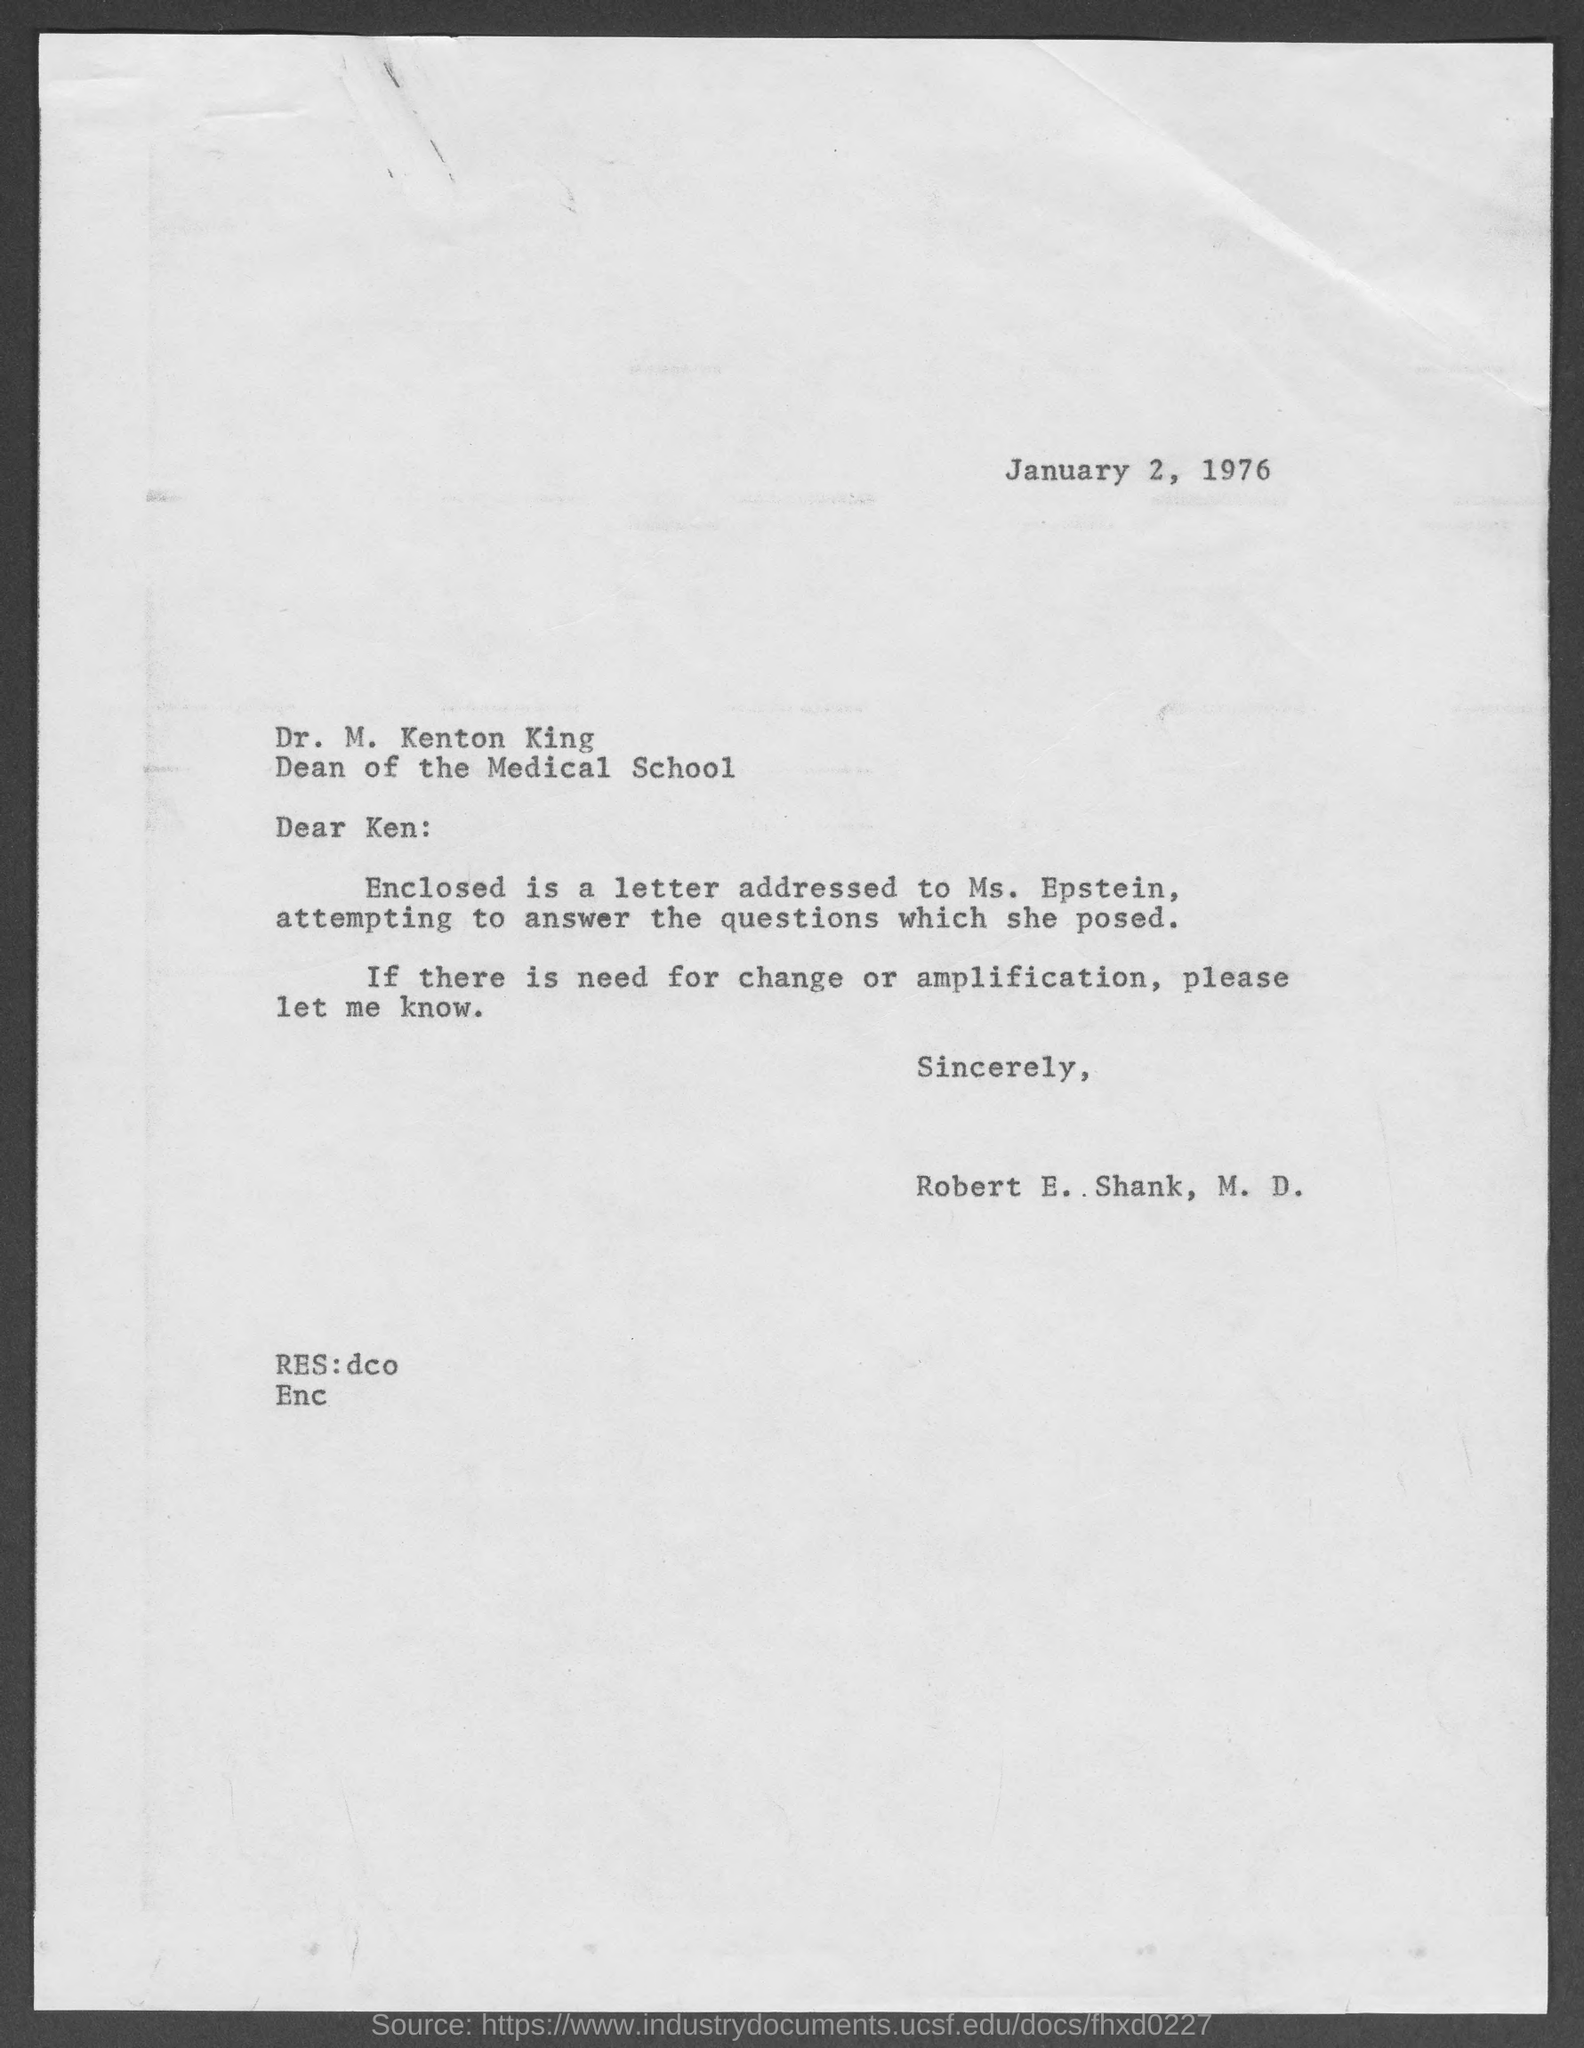When is the document dated?
Your answer should be very brief. January 2, 1976. To whom is the letter addressed?
Keep it short and to the point. Dr. M. Kenton King. What is the designation of Ken?
Ensure brevity in your answer.  Dean of the Medical School. Who is the sender?
Give a very brief answer. Robert E. Shank. To whom is the enclosed letter addressed?
Provide a succinct answer. Ms. Epstein. 